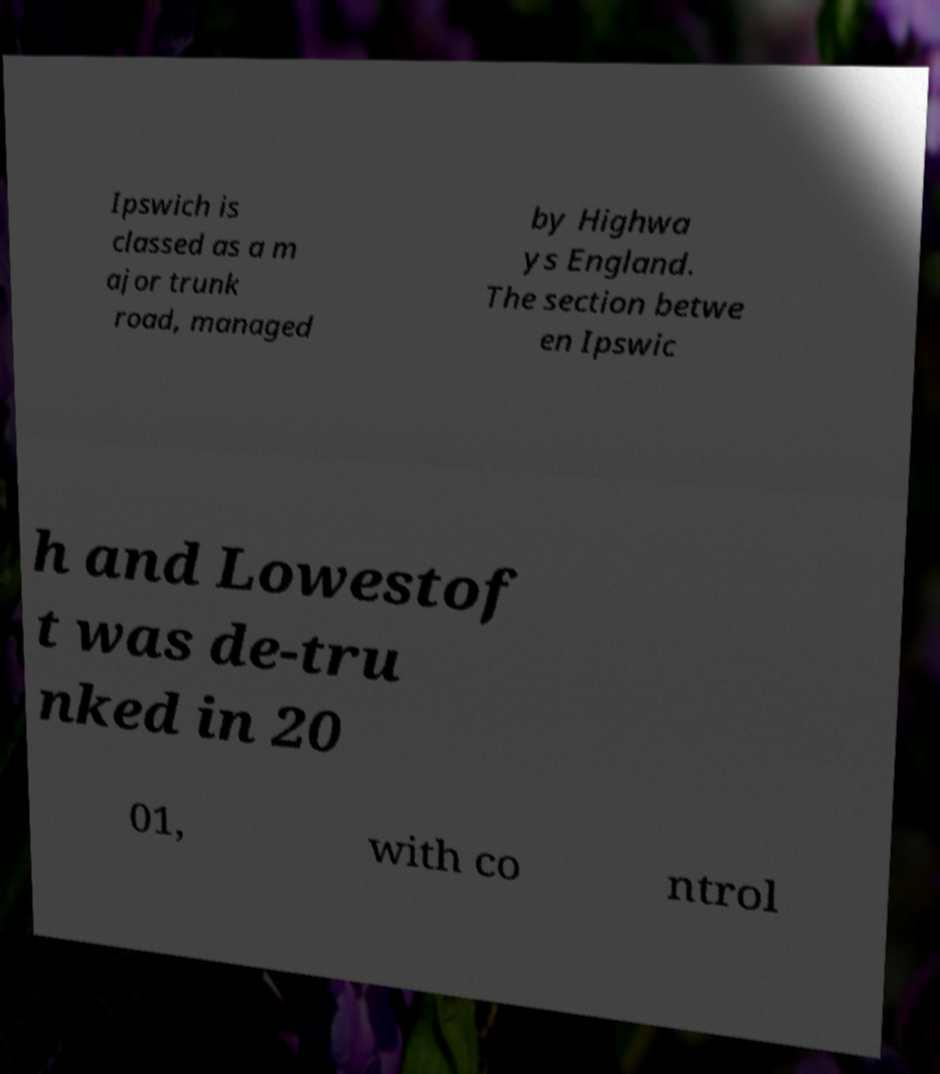Can you read and provide the text displayed in the image?This photo seems to have some interesting text. Can you extract and type it out for me? Ipswich is classed as a m ajor trunk road, managed by Highwa ys England. The section betwe en Ipswic h and Lowestof t was de-tru nked in 20 01, with co ntrol 